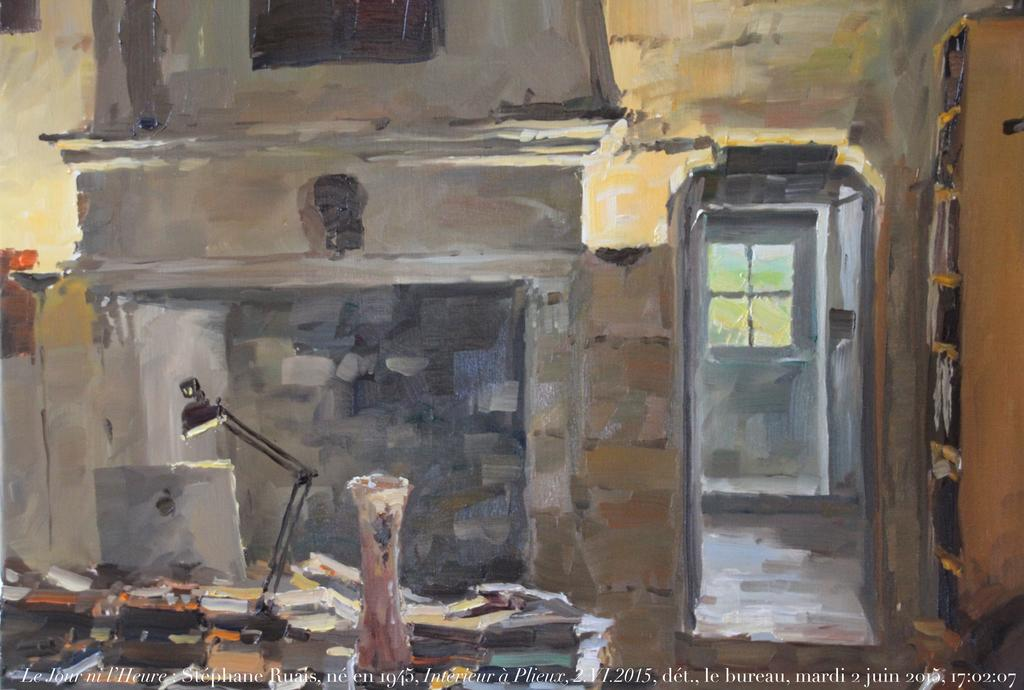<image>
Offer a succinct explanation of the picture presented. A painting with the numbers 17:02:07 at the bottom 